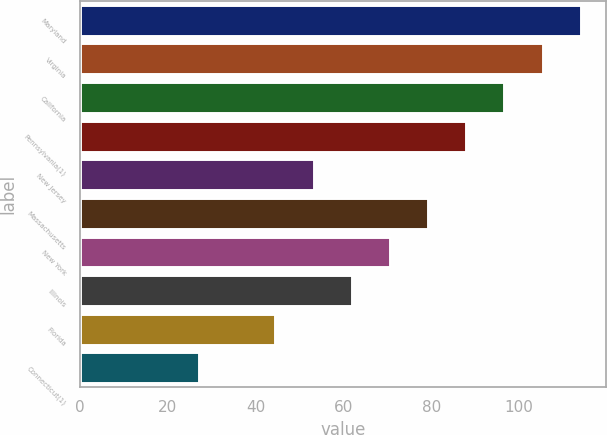Convert chart. <chart><loc_0><loc_0><loc_500><loc_500><bar_chart><fcel>Maryland<fcel>Virginia<fcel>California<fcel>Pennsylvania(1)<fcel>New Jersey<fcel>Massachusetts<fcel>New York<fcel>Illinois<fcel>Florida<fcel>Connecticut(1)<nl><fcel>114.1<fcel>105.4<fcel>96.7<fcel>88<fcel>53.2<fcel>79.3<fcel>70.6<fcel>61.9<fcel>44.5<fcel>27.1<nl></chart> 